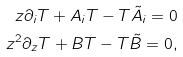<formula> <loc_0><loc_0><loc_500><loc_500>z \partial _ { i } T + A _ { i } T - T \tilde { A } _ { i } = 0 \\ z ^ { 2 } \partial _ { z } T + B T - T \tilde { B } = 0 ,</formula> 